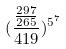<formula> <loc_0><loc_0><loc_500><loc_500>( \frac { \frac { 2 9 7 } { 2 6 5 } } { 4 1 9 } ) ^ { 5 ^ { 7 } }</formula> 